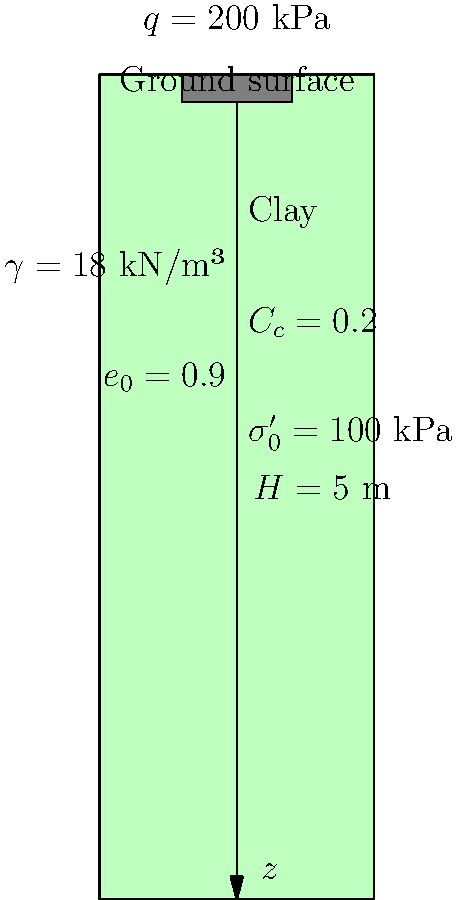Given the soil profile shown in the diagram, calculate the settlement of the foundation under the applied load. The foundation applies a pressure of 200 kPa on the clay layer. The clay layer has a thickness of 5 m, an initial void ratio ($e_0$) of 0.9, a compression index ($C_c$) of 0.2, and an initial effective stress ($\sigma'_0$) of 100 kPa at the middle of the layer. The unit weight of the clay is 18 kN/m³. To calculate the settlement of the foundation, we'll use the consolidation settlement equation for normally consolidated clays:

$$S = \frac{C_c H}{1 + e_0} \log_{10}\left(\frac{\sigma'_0 + \Delta\sigma}{\sigma'_0}\right)$$

Where:
$S$ = Settlement
$C_c$ = Compression index
$H$ = Thickness of the clay layer
$e_0$ = Initial void ratio
$\sigma'_0$ = Initial effective stress
$\Delta\sigma$ = Change in stress due to the applied load

Step 1: Determine $\Delta\sigma$
The change in stress is equal to the applied pressure:
$\Delta\sigma = 200$ kPa

Step 2: Calculate the settlement using the equation
$$S = \frac{0.2 \times 5}{1 + 0.9} \log_{10}\left(\frac{100 + 200}{100}\right)$$

Step 3: Simplify and solve
$$S = \frac{1}{1.9} \log_{10}(3)$$
$$S = 0.526 \times 0.477$$
$$S = 0.251 \text{ m}$$

Step 4: Convert to centimeters
$$S = 0.251 \text{ m} \times 100 \text{ cm/m} = 25.1 \text{ cm}$$

Therefore, the settlement of the foundation under the given load is approximately 25.1 cm.
Answer: 25.1 cm 